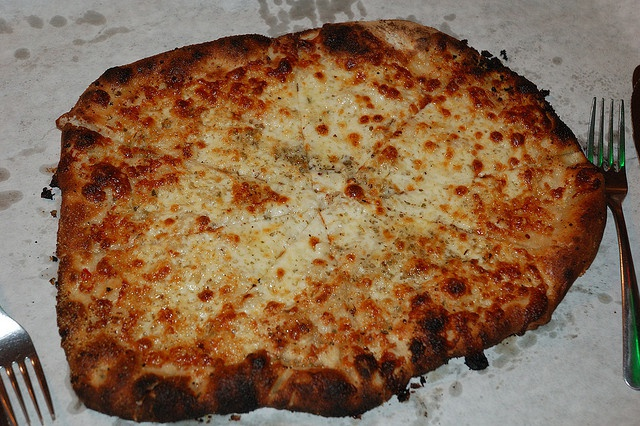Describe the objects in this image and their specific colors. I can see pizza in darkgray, brown, maroon, tan, and black tones, fork in darkgray, black, gray, and darkgreen tones, and fork in darkgray, black, gray, maroon, and white tones in this image. 